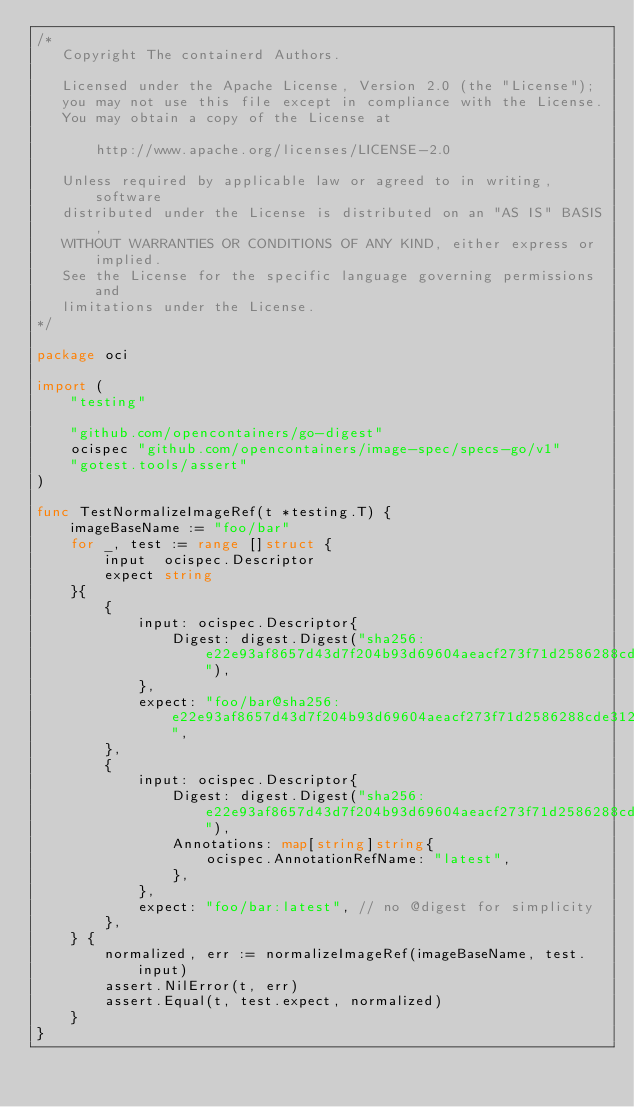<code> <loc_0><loc_0><loc_500><loc_500><_Go_>/*
   Copyright The containerd Authors.

   Licensed under the Apache License, Version 2.0 (the "License");
   you may not use this file except in compliance with the License.
   You may obtain a copy of the License at

       http://www.apache.org/licenses/LICENSE-2.0

   Unless required by applicable law or agreed to in writing, software
   distributed under the License is distributed on an "AS IS" BASIS,
   WITHOUT WARRANTIES OR CONDITIONS OF ANY KIND, either express or implied.
   See the License for the specific language governing permissions and
   limitations under the License.
*/

package oci

import (
	"testing"

	"github.com/opencontainers/go-digest"
	ocispec "github.com/opencontainers/image-spec/specs-go/v1"
	"gotest.tools/assert"
)

func TestNormalizeImageRef(t *testing.T) {
	imageBaseName := "foo/bar"
	for _, test := range []struct {
		input  ocispec.Descriptor
		expect string
	}{
		{
			input: ocispec.Descriptor{
				Digest: digest.Digest("sha256:e22e93af8657d43d7f204b93d69604aeacf273f71d2586288cde312808c0ec77"),
			},
			expect: "foo/bar@sha256:e22e93af8657d43d7f204b93d69604aeacf273f71d2586288cde312808c0ec77",
		},
		{
			input: ocispec.Descriptor{
				Digest: digest.Digest("sha256:e22e93af8657d43d7f204b93d69604aeacf273f71d2586288cde312808c0ec77"),
				Annotations: map[string]string{
					ocispec.AnnotationRefName: "latest",
				},
			},
			expect: "foo/bar:latest", // no @digest for simplicity
		},
	} {
		normalized, err := normalizeImageRef(imageBaseName, test.input)
		assert.NilError(t, err)
		assert.Equal(t, test.expect, normalized)
	}
}
</code> 